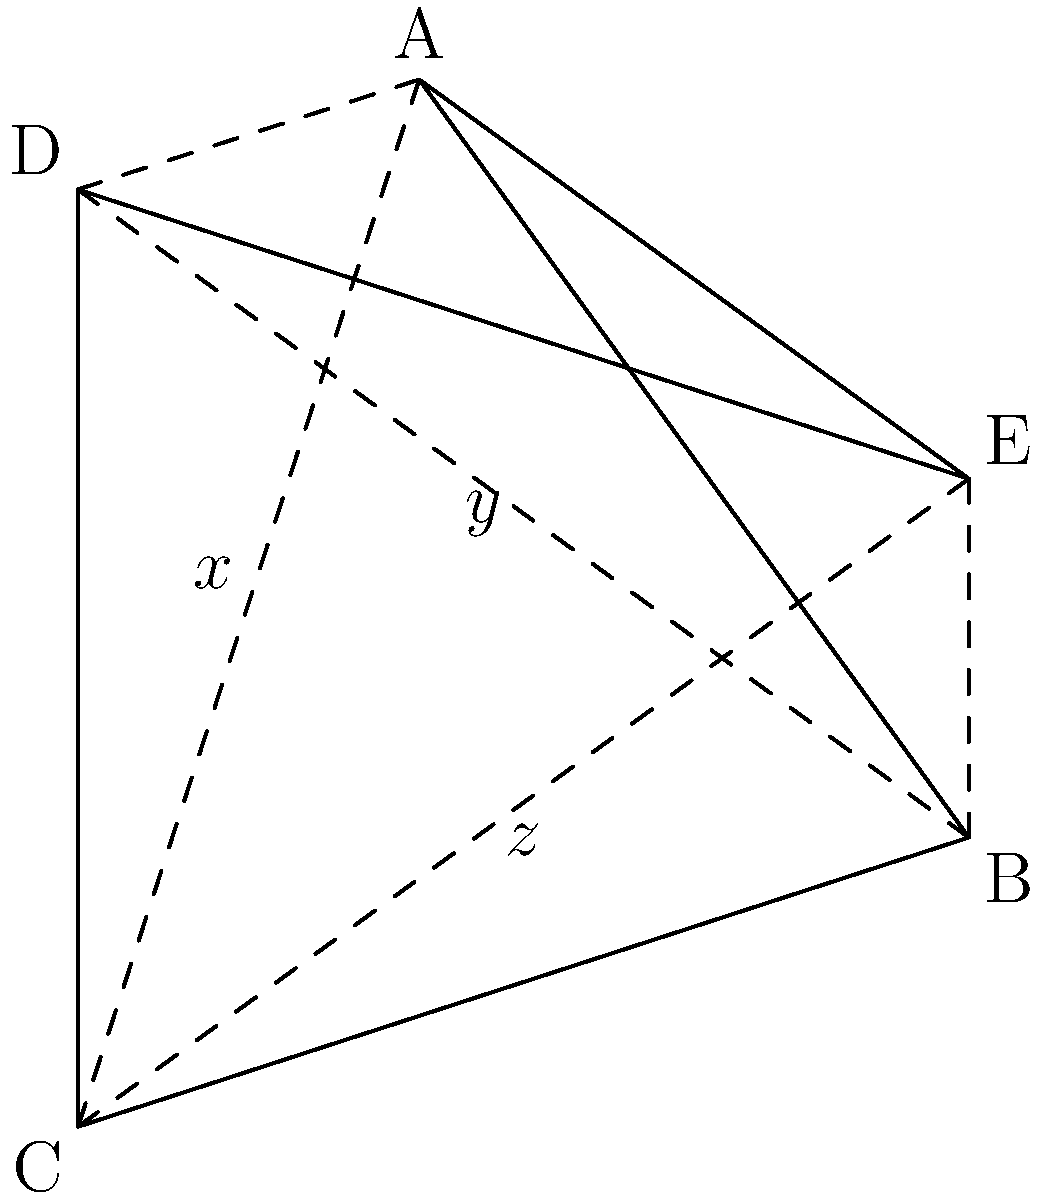In the star-shaped pentagon ABCDE representing a family (parents at A and B, children at C, D, and E), the angles at each point are all equal. If the measure of angle BAE is $36^\circ$, find the measures of angles $x$, $y$, and $z$ formed by the intersecting diagonals. Let's approach this step-by-step:

1) In a regular pentagon, each interior angle measures $(540^\circ / 5) = 108^\circ$.

2) The angle at each point of the star is $(180^\circ - 108^\circ) = 72^\circ$.

3) We're given that angle BAE is $36^\circ$, which is half of $72^\circ$. This confirms that the pentagon is regular.

4) In a regular star pentagon, all the angles formed by the intersecting diagonals are equal. Let's call this angle $\theta$.

5) At point A, we have: $\theta + \theta + 36^\circ = 180^\circ$ (sum of angles on a straight line)

6) Solving this equation:
   $2\theta + 36^\circ = 180^\circ$
   $2\theta = 144^\circ$
   $\theta = 72^\circ$

7) Therefore, $x = y = z = 72^\circ$

This star shape symbolizes the unity of the adoptive family, with each point representing a family member and the intersecting lines showing their interconnectedness.
Answer: $x = y = z = 72^\circ$ 